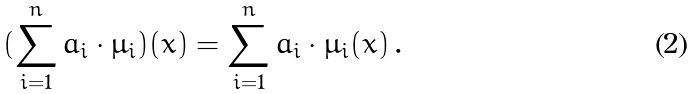Convert formula to latex. <formula><loc_0><loc_0><loc_500><loc_500>( \sum _ { i = 1 } ^ { n } a _ { i } \cdot \mu _ { i } ) ( x ) = \sum _ { i = 1 } ^ { n } a _ { i } \cdot \mu _ { i } ( x ) \, .</formula> 